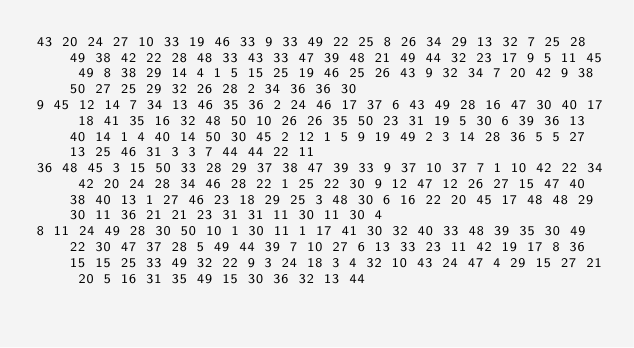<code> <loc_0><loc_0><loc_500><loc_500><_Matlab_>43 20 24 27 10 33 19 46 33 9 33 49 22 25 8 26 34 29 13 32 7 25 28 49 38 42 22 28 48 33 43 33 47 39 48 21 49 44 32 23 17 9 5 11 45 49 8 38 29 14 4 1 5 15 25 19 46 25 26 43 9 32 34 7 20 42 9 38 50 27 25 29 32 26 28 2 34 36 36 30
9 45 12 14 7 34 13 46 35 36 2 24 46 17 37 6 43 49 28 16 47 30 40 17 18 41 35 16 32 48 50 10 26 26 35 50 23 31 19 5 30 6 39 36 13 40 14 1 4 40 14 50 30 45 2 12 1 5 9 19 49 2 3 14 28 36 5 5 27 13 25 46 31 3 3 7 44 44 22 11
36 48 45 3 15 50 33 28 29 37 38 47 39 33 9 37 10 37 7 1 10 42 22 34 42 20 24 28 34 46 28 22 1 25 22 30 9 12 47 12 26 27 15 47 40 38 40 13 1 27 46 23 18 29 25 3 48 30 6 16 22 20 45 17 48 48 29 30 11 36 21 21 23 31 31 11 30 11 30 4
8 11 24 49 28 30 50 10 1 30 11 1 17 41 30 32 40 33 48 39 35 30 49 22 30 47 37 28 5 49 44 39 7 10 27 6 13 33 23 11 42 19 17 8 36 15 15 25 33 49 32 22 9 3 24 18 3 4 32 10 43 24 47 4 29 15 27 21 20 5 16 31 35 49 15 30 36 32 13 44</code> 